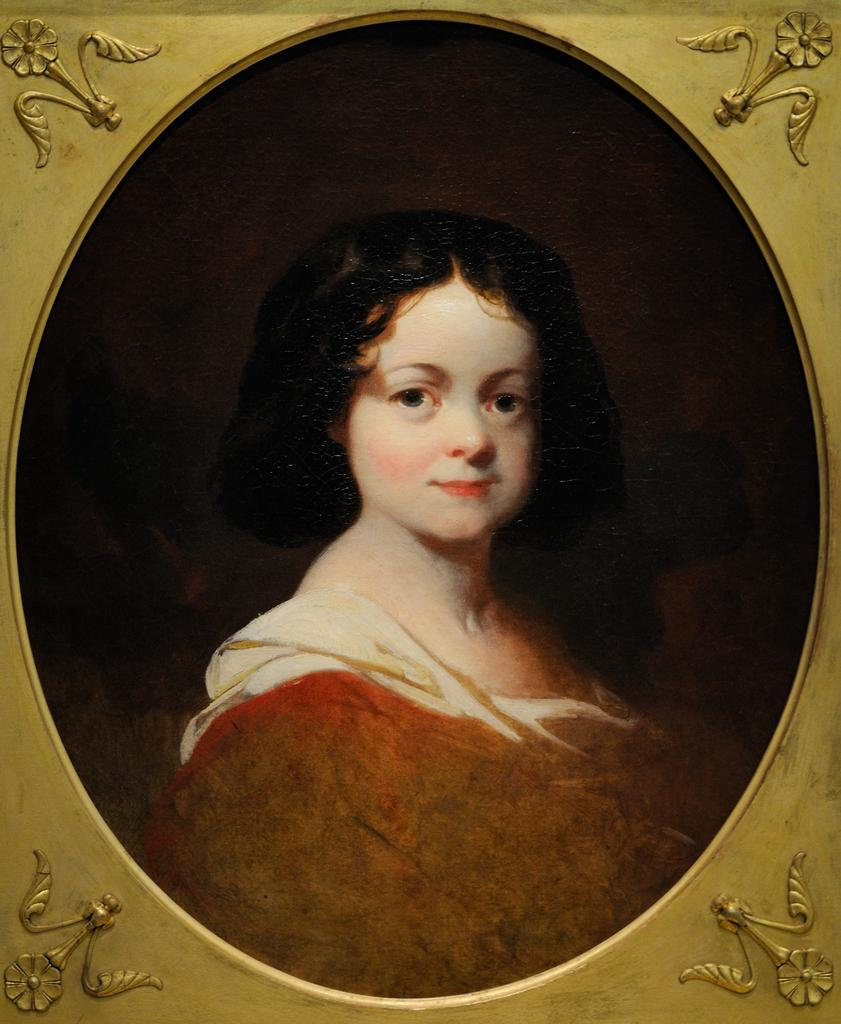What object is present in the image that typically holds a picture? There is a photo frame in the image. Who is depicted in the picture inside the frame? The photo frame contains a picture of a woman. What decorative elements are present on the photo frame? There are flowers on the four sides of the frame. What type of drum is the woman playing in the image? There is no drum present in the image; it features a photo frame with a picture of a woman. How much milk is visible in the image? There is no milk present in the image. 